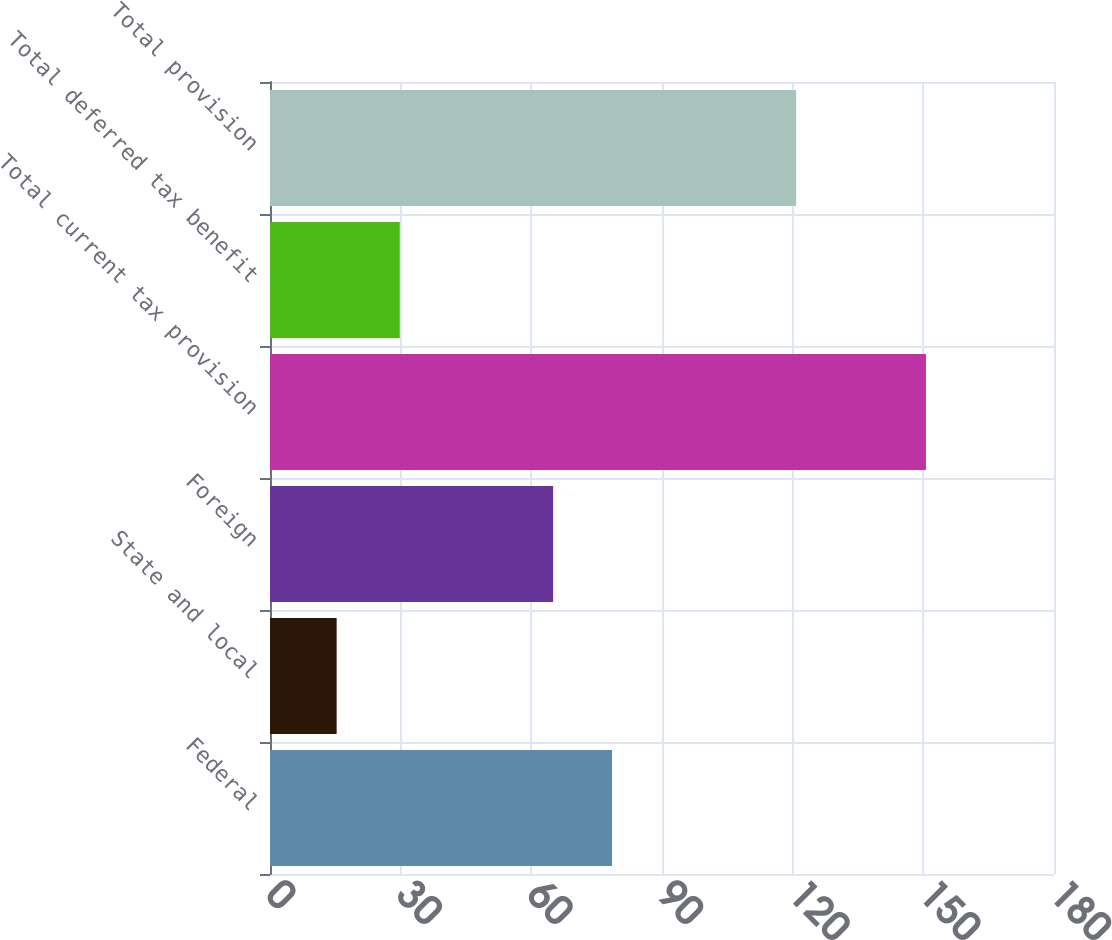<chart> <loc_0><loc_0><loc_500><loc_500><bar_chart><fcel>Federal<fcel>State and local<fcel>Foreign<fcel>Total current tax provision<fcel>Total deferred tax benefit<fcel>Total provision<nl><fcel>78.53<fcel>15.3<fcel>65<fcel>150.6<fcel>29.8<fcel>120.8<nl></chart> 